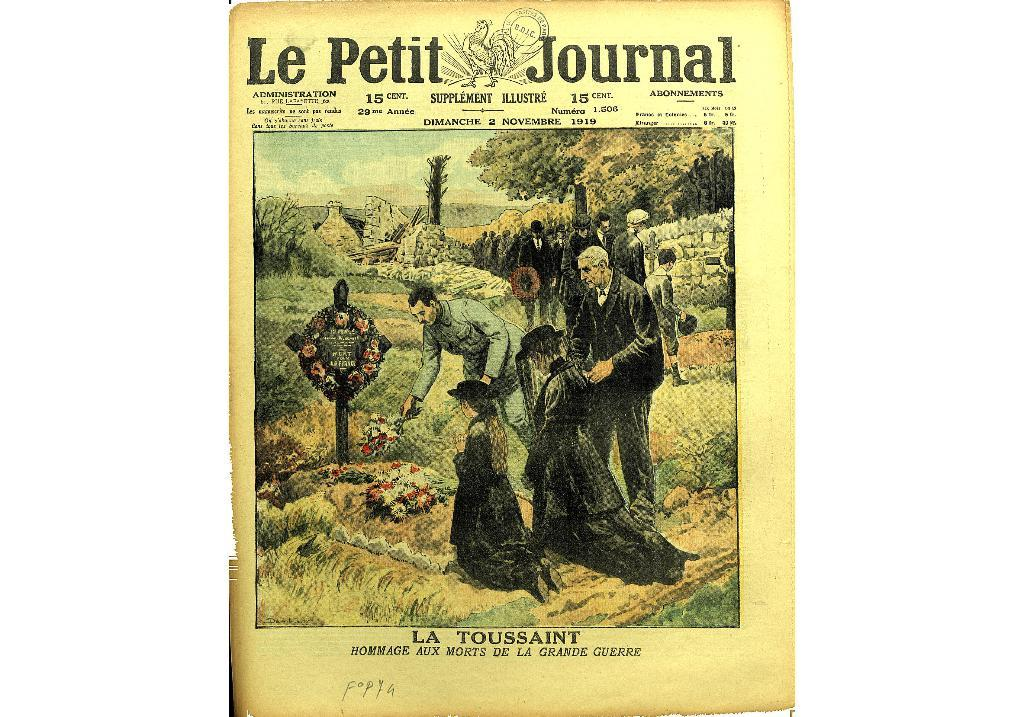<image>
Give a short and clear explanation of the subsequent image. a piece of paper with Le Petit Journal written on it 